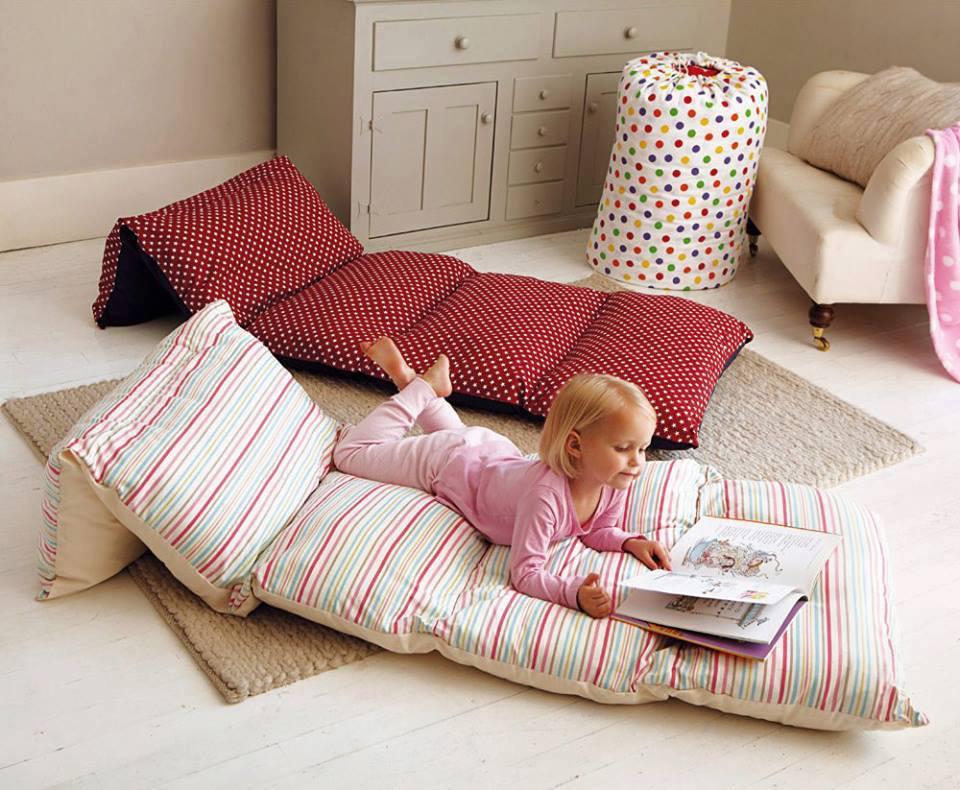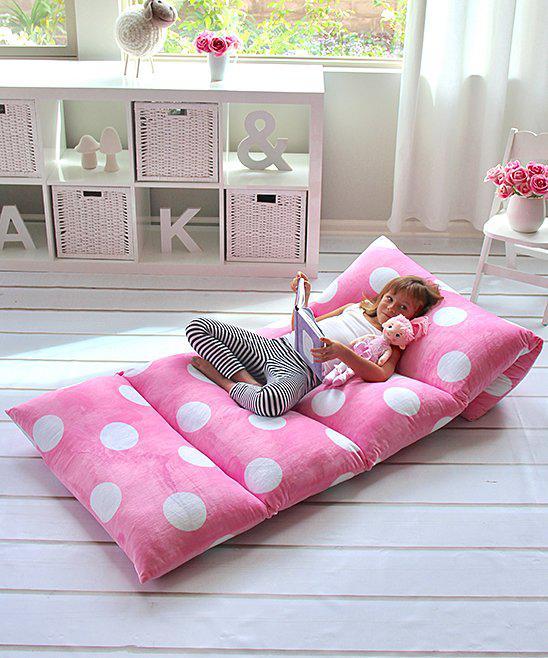The first image is the image on the left, the second image is the image on the right. For the images shown, is this caption "In the left image two kids are holding pillows" true? Answer yes or no. No. 